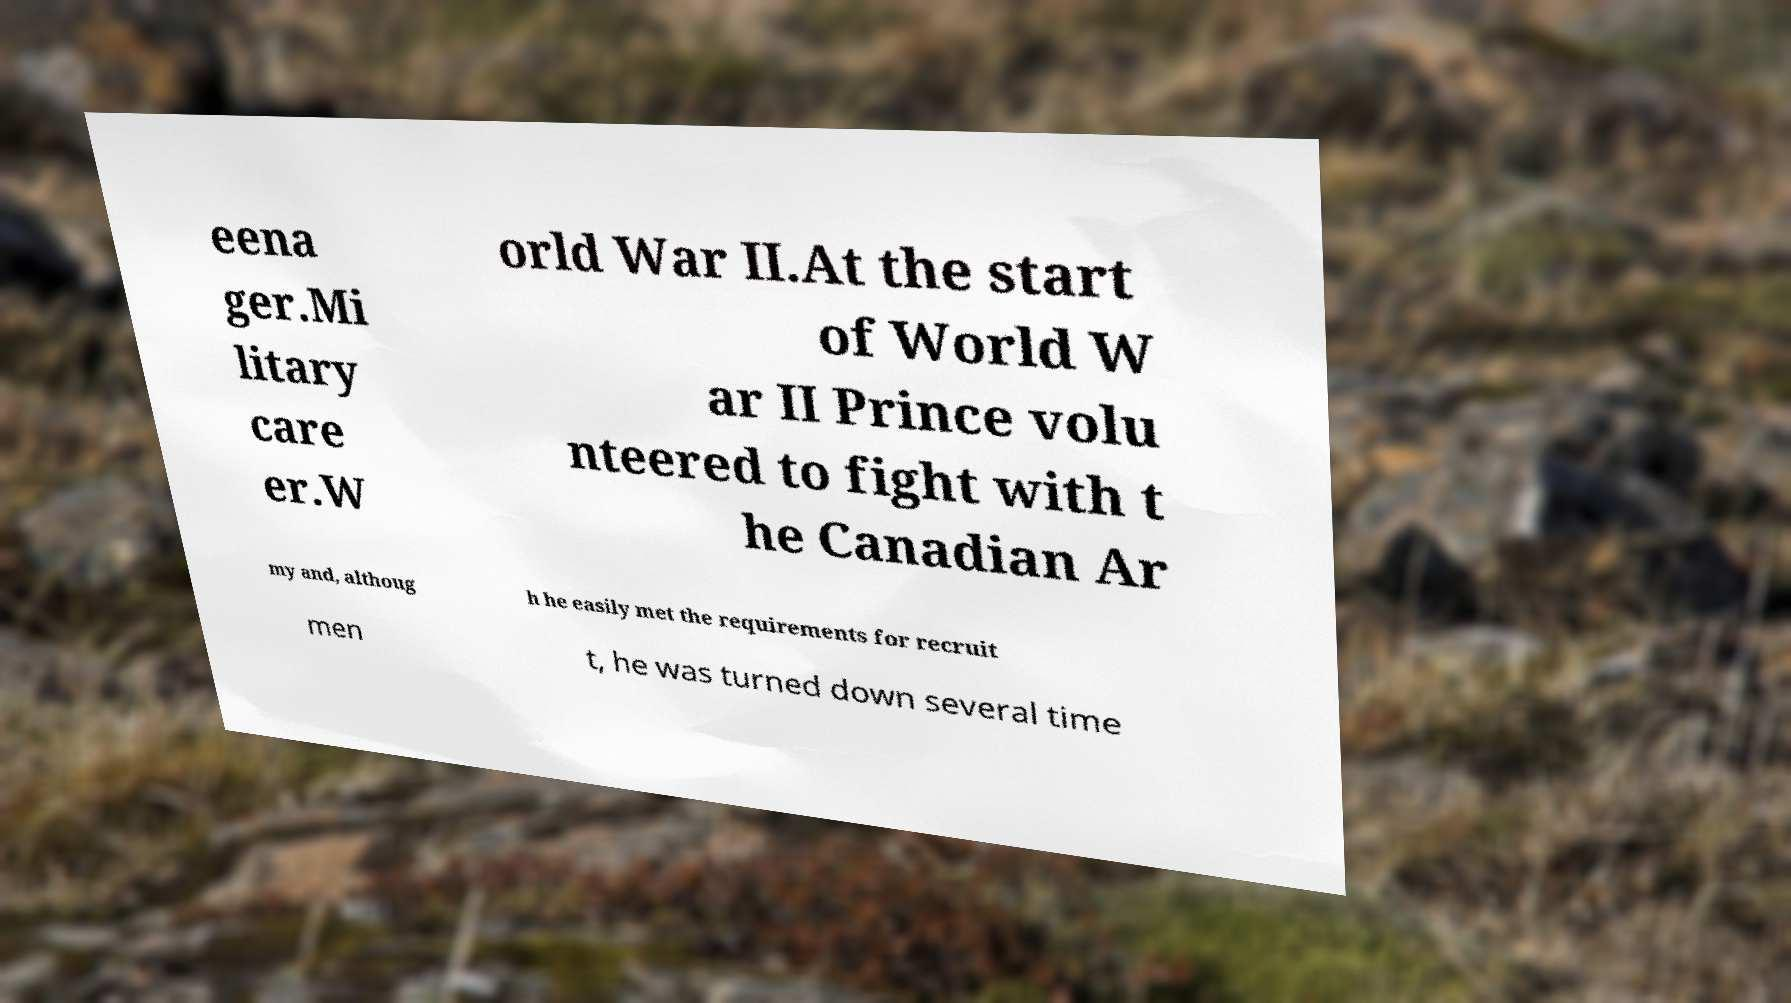Can you accurately transcribe the text from the provided image for me? eena ger.Mi litary care er.W orld War II.At the start of World W ar II Prince volu nteered to fight with t he Canadian Ar my and, althoug h he easily met the requirements for recruit men t, he was turned down several time 